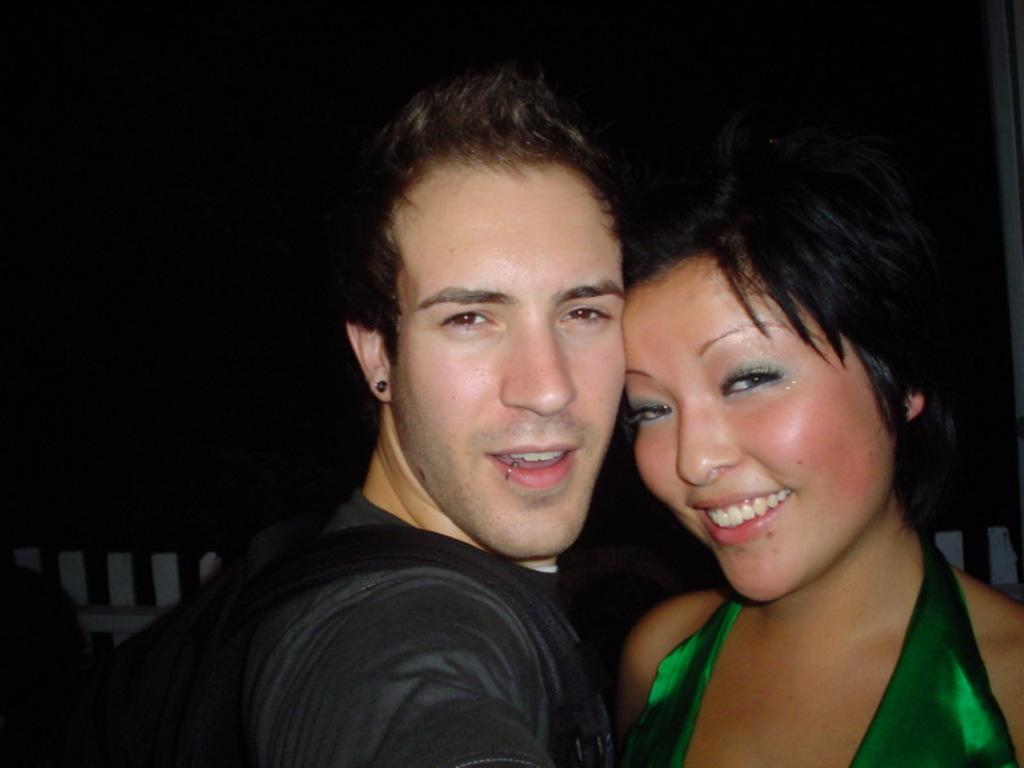Who are the people in the image? There is a man and a lady in the image. What can be seen in the background of the image? There is a fence in the background of the image. What type of skin condition does the lady have in the image? There is no indication of any skin condition in the image; the lady's skin appears normal. 